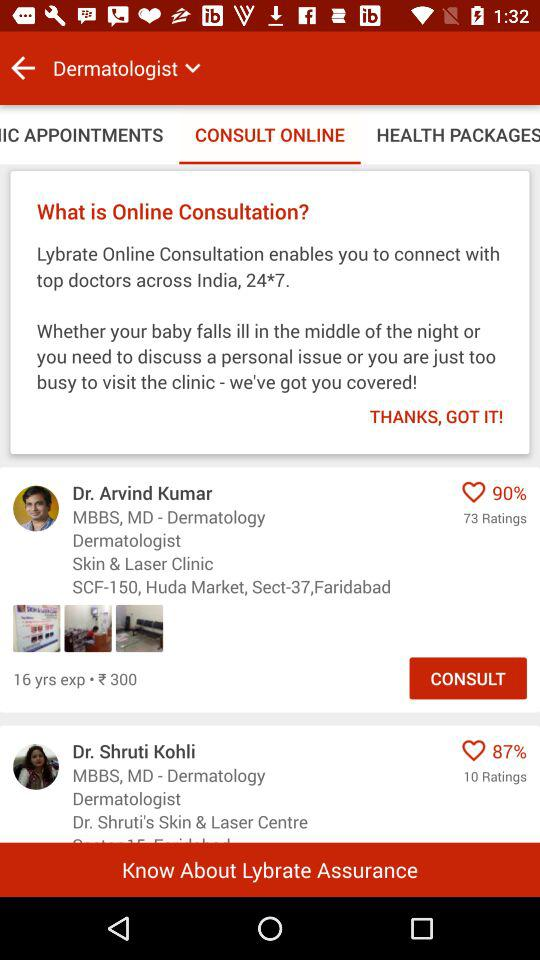How much does Dr. Arvind Kumar charge? Dr. Arvind Kumar charges ₹300. 